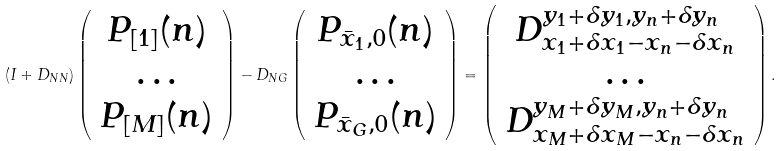<formula> <loc_0><loc_0><loc_500><loc_500>( I + D _ { N N } ) \left ( \begin{array} { c } P _ { [ 1 ] } ( n ) \\ \dots \\ P _ { [ M ] } ( n ) \\ \end{array} \right ) - D _ { N G } \left ( \begin{array} { c } P _ { \bar { x } _ { 1 } , 0 } ( n ) \\ \dots \\ P _ { \bar { x } _ { G } , 0 } ( n ) \\ \end{array} \right ) = \left ( \begin{array} { c } D ^ { y _ { 1 } + \delta y _ { 1 } , y _ { n } + \delta y _ { n } } _ { x _ { 1 } + \delta x _ { 1 } - x _ { n } - \delta x _ { n } } \\ \dots \\ D ^ { y _ { M } + \delta y _ { M } , y _ { n } + \delta y _ { n } } _ { x _ { M } + \delta x _ { M } - x _ { n } - \delta x _ { n } } \\ \end{array} \right ) .</formula> 